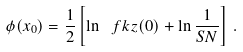<formula> <loc_0><loc_0><loc_500><loc_500>\phi ( x _ { 0 } ) = \frac { 1 } { 2 } \left [ \ln \ f k z ( 0 ) + \ln \frac { 1 } { S N } \right ] \, .</formula> 